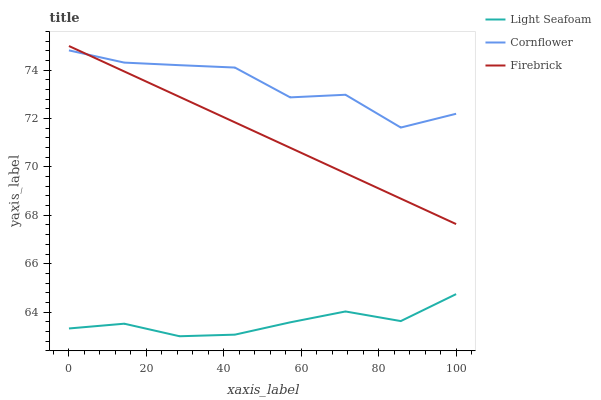Does Firebrick have the minimum area under the curve?
Answer yes or no. No. Does Firebrick have the maximum area under the curve?
Answer yes or no. No. Is Light Seafoam the smoothest?
Answer yes or no. No. Is Light Seafoam the roughest?
Answer yes or no. No. Does Firebrick have the lowest value?
Answer yes or no. No. Does Light Seafoam have the highest value?
Answer yes or no. No. Is Light Seafoam less than Cornflower?
Answer yes or no. Yes. Is Cornflower greater than Light Seafoam?
Answer yes or no. Yes. Does Light Seafoam intersect Cornflower?
Answer yes or no. No. 